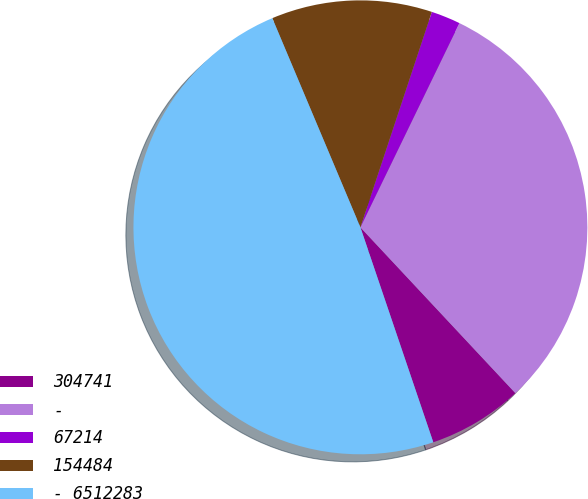Convert chart. <chart><loc_0><loc_0><loc_500><loc_500><pie_chart><fcel>304741<fcel>-<fcel>67214<fcel>154484<fcel>- 6512283<nl><fcel>6.76%<fcel>30.85%<fcel>2.09%<fcel>11.44%<fcel>48.86%<nl></chart> 